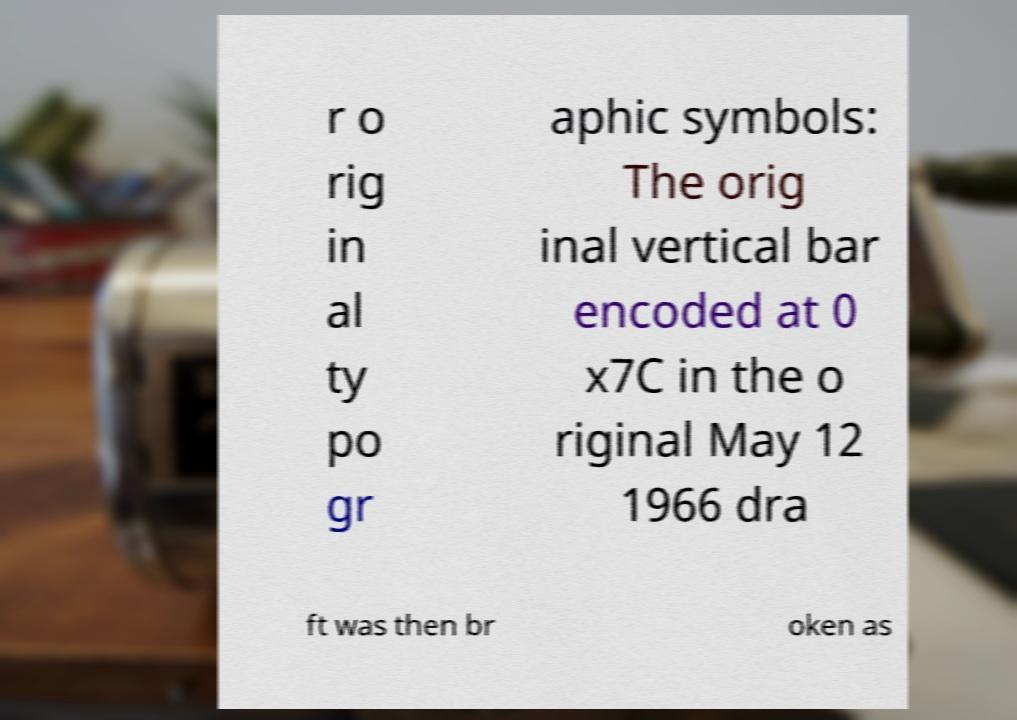Please read and relay the text visible in this image. What does it say? r o rig in al ty po gr aphic symbols: The orig inal vertical bar encoded at 0 x7C in the o riginal May 12 1966 dra ft was then br oken as 